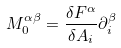<formula> <loc_0><loc_0><loc_500><loc_500>M _ { 0 } ^ { \alpha \beta } = \frac { \delta F ^ { \alpha } } { \delta A _ { i } } \partial _ { i } ^ { \beta }</formula> 